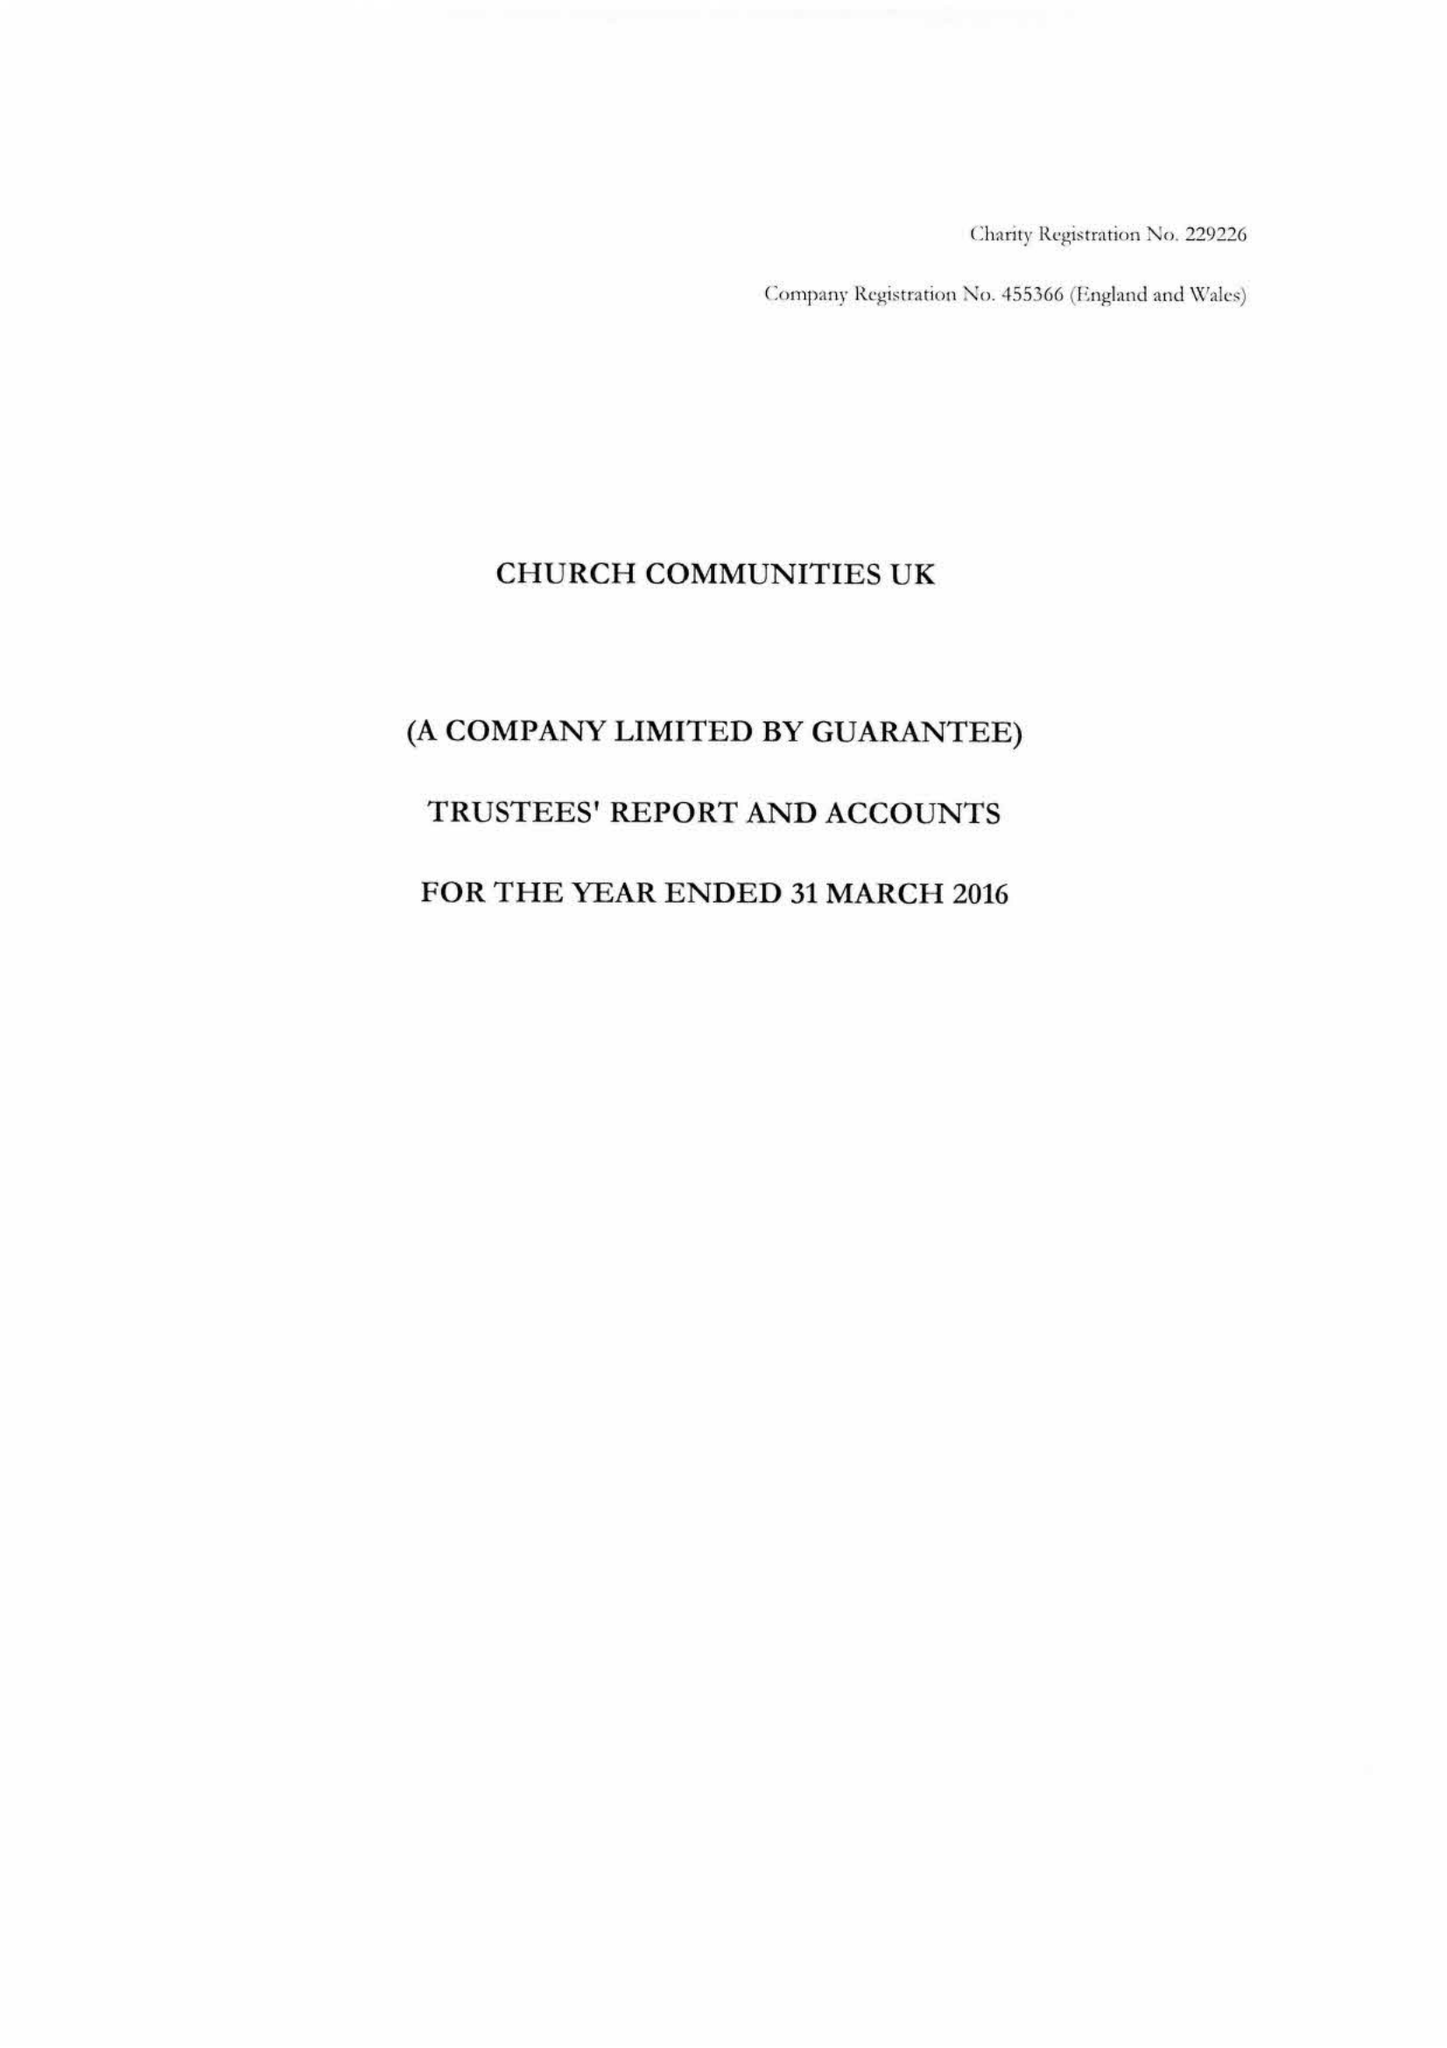What is the value for the report_date?
Answer the question using a single word or phrase. 2016-03-31 